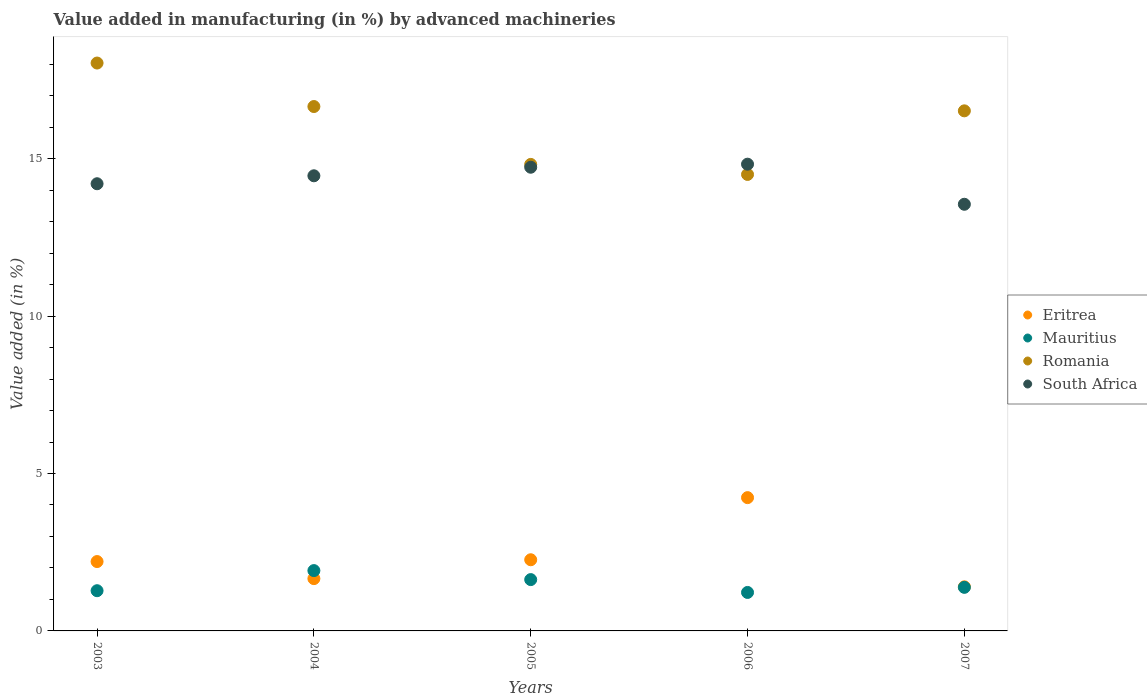How many different coloured dotlines are there?
Offer a very short reply. 4. Is the number of dotlines equal to the number of legend labels?
Offer a very short reply. Yes. What is the percentage of value added in manufacturing by advanced machineries in South Africa in 2003?
Offer a terse response. 14.2. Across all years, what is the maximum percentage of value added in manufacturing by advanced machineries in Eritrea?
Keep it short and to the point. 4.23. Across all years, what is the minimum percentage of value added in manufacturing by advanced machineries in Eritrea?
Provide a short and direct response. 1.4. In which year was the percentage of value added in manufacturing by advanced machineries in South Africa maximum?
Make the answer very short. 2006. In which year was the percentage of value added in manufacturing by advanced machineries in Mauritius minimum?
Give a very brief answer. 2006. What is the total percentage of value added in manufacturing by advanced machineries in Eritrea in the graph?
Your answer should be compact. 11.76. What is the difference between the percentage of value added in manufacturing by advanced machineries in Eritrea in 2003 and that in 2006?
Keep it short and to the point. -2.03. What is the difference between the percentage of value added in manufacturing by advanced machineries in Romania in 2006 and the percentage of value added in manufacturing by advanced machineries in South Africa in 2004?
Offer a very short reply. 0.04. What is the average percentage of value added in manufacturing by advanced machineries in Eritrea per year?
Provide a short and direct response. 2.35. In the year 2005, what is the difference between the percentage of value added in manufacturing by advanced machineries in Romania and percentage of value added in manufacturing by advanced machineries in Mauritius?
Make the answer very short. 13.19. In how many years, is the percentage of value added in manufacturing by advanced machineries in South Africa greater than 3 %?
Your answer should be compact. 5. What is the ratio of the percentage of value added in manufacturing by advanced machineries in Mauritius in 2004 to that in 2007?
Offer a very short reply. 1.38. Is the percentage of value added in manufacturing by advanced machineries in South Africa in 2004 less than that in 2006?
Your answer should be compact. Yes. Is the difference between the percentage of value added in manufacturing by advanced machineries in Romania in 2003 and 2004 greater than the difference between the percentage of value added in manufacturing by advanced machineries in Mauritius in 2003 and 2004?
Keep it short and to the point. Yes. What is the difference between the highest and the second highest percentage of value added in manufacturing by advanced machineries in Romania?
Your answer should be very brief. 1.38. What is the difference between the highest and the lowest percentage of value added in manufacturing by advanced machineries in South Africa?
Make the answer very short. 1.27. In how many years, is the percentage of value added in manufacturing by advanced machineries in Mauritius greater than the average percentage of value added in manufacturing by advanced machineries in Mauritius taken over all years?
Provide a succinct answer. 2. Is it the case that in every year, the sum of the percentage of value added in manufacturing by advanced machineries in Mauritius and percentage of value added in manufacturing by advanced machineries in South Africa  is greater than the sum of percentage of value added in manufacturing by advanced machineries in Eritrea and percentage of value added in manufacturing by advanced machineries in Romania?
Ensure brevity in your answer.  Yes. Is the percentage of value added in manufacturing by advanced machineries in Eritrea strictly greater than the percentage of value added in manufacturing by advanced machineries in South Africa over the years?
Your answer should be compact. No. Is the percentage of value added in manufacturing by advanced machineries in Romania strictly less than the percentage of value added in manufacturing by advanced machineries in Mauritius over the years?
Provide a succinct answer. No. How many dotlines are there?
Your answer should be compact. 4. What is the difference between two consecutive major ticks on the Y-axis?
Make the answer very short. 5. Are the values on the major ticks of Y-axis written in scientific E-notation?
Your answer should be very brief. No. Does the graph contain grids?
Make the answer very short. No. Where does the legend appear in the graph?
Offer a terse response. Center right. How many legend labels are there?
Your answer should be compact. 4. How are the legend labels stacked?
Make the answer very short. Vertical. What is the title of the graph?
Make the answer very short. Value added in manufacturing (in %) by advanced machineries. Does "Myanmar" appear as one of the legend labels in the graph?
Offer a terse response. No. What is the label or title of the Y-axis?
Your response must be concise. Value added (in %). What is the Value added (in %) in Eritrea in 2003?
Keep it short and to the point. 2.2. What is the Value added (in %) of Mauritius in 2003?
Give a very brief answer. 1.28. What is the Value added (in %) of Romania in 2003?
Make the answer very short. 18.04. What is the Value added (in %) in South Africa in 2003?
Give a very brief answer. 14.2. What is the Value added (in %) in Eritrea in 2004?
Offer a very short reply. 1.66. What is the Value added (in %) of Mauritius in 2004?
Keep it short and to the point. 1.92. What is the Value added (in %) in Romania in 2004?
Offer a very short reply. 16.65. What is the Value added (in %) in South Africa in 2004?
Your answer should be compact. 14.45. What is the Value added (in %) in Eritrea in 2005?
Your answer should be very brief. 2.26. What is the Value added (in %) of Mauritius in 2005?
Offer a very short reply. 1.63. What is the Value added (in %) of Romania in 2005?
Make the answer very short. 14.82. What is the Value added (in %) of South Africa in 2005?
Keep it short and to the point. 14.73. What is the Value added (in %) of Eritrea in 2006?
Keep it short and to the point. 4.23. What is the Value added (in %) of Mauritius in 2006?
Offer a terse response. 1.22. What is the Value added (in %) in Romania in 2006?
Offer a very short reply. 14.5. What is the Value added (in %) in South Africa in 2006?
Your response must be concise. 14.82. What is the Value added (in %) in Eritrea in 2007?
Ensure brevity in your answer.  1.4. What is the Value added (in %) of Mauritius in 2007?
Keep it short and to the point. 1.38. What is the Value added (in %) of Romania in 2007?
Give a very brief answer. 16.52. What is the Value added (in %) of South Africa in 2007?
Make the answer very short. 13.55. Across all years, what is the maximum Value added (in %) of Eritrea?
Make the answer very short. 4.23. Across all years, what is the maximum Value added (in %) of Mauritius?
Your response must be concise. 1.92. Across all years, what is the maximum Value added (in %) in Romania?
Ensure brevity in your answer.  18.04. Across all years, what is the maximum Value added (in %) in South Africa?
Make the answer very short. 14.82. Across all years, what is the minimum Value added (in %) in Eritrea?
Your answer should be compact. 1.4. Across all years, what is the minimum Value added (in %) in Mauritius?
Your answer should be very brief. 1.22. Across all years, what is the minimum Value added (in %) of Romania?
Keep it short and to the point. 14.5. Across all years, what is the minimum Value added (in %) of South Africa?
Your response must be concise. 13.55. What is the total Value added (in %) of Eritrea in the graph?
Make the answer very short. 11.76. What is the total Value added (in %) in Mauritius in the graph?
Give a very brief answer. 7.43. What is the total Value added (in %) of Romania in the graph?
Keep it short and to the point. 80.52. What is the total Value added (in %) in South Africa in the graph?
Provide a succinct answer. 71.76. What is the difference between the Value added (in %) in Eritrea in 2003 and that in 2004?
Keep it short and to the point. 0.54. What is the difference between the Value added (in %) in Mauritius in 2003 and that in 2004?
Provide a succinct answer. -0.64. What is the difference between the Value added (in %) in Romania in 2003 and that in 2004?
Provide a succinct answer. 1.38. What is the difference between the Value added (in %) in South Africa in 2003 and that in 2004?
Your answer should be very brief. -0.25. What is the difference between the Value added (in %) of Eritrea in 2003 and that in 2005?
Offer a very short reply. -0.06. What is the difference between the Value added (in %) of Mauritius in 2003 and that in 2005?
Make the answer very short. -0.35. What is the difference between the Value added (in %) in Romania in 2003 and that in 2005?
Your answer should be compact. 3.22. What is the difference between the Value added (in %) of South Africa in 2003 and that in 2005?
Provide a succinct answer. -0.52. What is the difference between the Value added (in %) of Eritrea in 2003 and that in 2006?
Give a very brief answer. -2.03. What is the difference between the Value added (in %) of Mauritius in 2003 and that in 2006?
Your answer should be compact. 0.06. What is the difference between the Value added (in %) of Romania in 2003 and that in 2006?
Your answer should be very brief. 3.54. What is the difference between the Value added (in %) in South Africa in 2003 and that in 2006?
Provide a succinct answer. -0.62. What is the difference between the Value added (in %) of Eritrea in 2003 and that in 2007?
Offer a very short reply. 0.8. What is the difference between the Value added (in %) of Mauritius in 2003 and that in 2007?
Keep it short and to the point. -0.11. What is the difference between the Value added (in %) of Romania in 2003 and that in 2007?
Provide a succinct answer. 1.52. What is the difference between the Value added (in %) in South Africa in 2003 and that in 2007?
Make the answer very short. 0.65. What is the difference between the Value added (in %) of Eritrea in 2004 and that in 2005?
Offer a very short reply. -0.6. What is the difference between the Value added (in %) in Mauritius in 2004 and that in 2005?
Provide a succinct answer. 0.29. What is the difference between the Value added (in %) in Romania in 2004 and that in 2005?
Make the answer very short. 1.84. What is the difference between the Value added (in %) in South Africa in 2004 and that in 2005?
Your answer should be compact. -0.27. What is the difference between the Value added (in %) in Eritrea in 2004 and that in 2006?
Make the answer very short. -2.57. What is the difference between the Value added (in %) of Mauritius in 2004 and that in 2006?
Offer a terse response. 0.69. What is the difference between the Value added (in %) of Romania in 2004 and that in 2006?
Ensure brevity in your answer.  2.16. What is the difference between the Value added (in %) in South Africa in 2004 and that in 2006?
Your answer should be very brief. -0.37. What is the difference between the Value added (in %) in Eritrea in 2004 and that in 2007?
Provide a short and direct response. 0.26. What is the difference between the Value added (in %) in Mauritius in 2004 and that in 2007?
Keep it short and to the point. 0.53. What is the difference between the Value added (in %) of Romania in 2004 and that in 2007?
Provide a succinct answer. 0.14. What is the difference between the Value added (in %) in South Africa in 2004 and that in 2007?
Your response must be concise. 0.9. What is the difference between the Value added (in %) of Eritrea in 2005 and that in 2006?
Provide a short and direct response. -1.97. What is the difference between the Value added (in %) of Mauritius in 2005 and that in 2006?
Offer a very short reply. 0.41. What is the difference between the Value added (in %) in Romania in 2005 and that in 2006?
Keep it short and to the point. 0.32. What is the difference between the Value added (in %) of South Africa in 2005 and that in 2006?
Provide a short and direct response. -0.1. What is the difference between the Value added (in %) in Eritrea in 2005 and that in 2007?
Your answer should be compact. 0.86. What is the difference between the Value added (in %) of Mauritius in 2005 and that in 2007?
Your answer should be very brief. 0.25. What is the difference between the Value added (in %) of Romania in 2005 and that in 2007?
Ensure brevity in your answer.  -1.7. What is the difference between the Value added (in %) in South Africa in 2005 and that in 2007?
Give a very brief answer. 1.18. What is the difference between the Value added (in %) of Eritrea in 2006 and that in 2007?
Ensure brevity in your answer.  2.83. What is the difference between the Value added (in %) in Mauritius in 2006 and that in 2007?
Give a very brief answer. -0.16. What is the difference between the Value added (in %) of Romania in 2006 and that in 2007?
Keep it short and to the point. -2.02. What is the difference between the Value added (in %) of South Africa in 2006 and that in 2007?
Keep it short and to the point. 1.27. What is the difference between the Value added (in %) in Eritrea in 2003 and the Value added (in %) in Mauritius in 2004?
Ensure brevity in your answer.  0.29. What is the difference between the Value added (in %) of Eritrea in 2003 and the Value added (in %) of Romania in 2004?
Provide a short and direct response. -14.45. What is the difference between the Value added (in %) in Eritrea in 2003 and the Value added (in %) in South Africa in 2004?
Provide a succinct answer. -12.25. What is the difference between the Value added (in %) of Mauritius in 2003 and the Value added (in %) of Romania in 2004?
Provide a succinct answer. -15.38. What is the difference between the Value added (in %) of Mauritius in 2003 and the Value added (in %) of South Africa in 2004?
Give a very brief answer. -13.18. What is the difference between the Value added (in %) in Romania in 2003 and the Value added (in %) in South Africa in 2004?
Give a very brief answer. 3.58. What is the difference between the Value added (in %) in Eritrea in 2003 and the Value added (in %) in Mauritius in 2005?
Your response must be concise. 0.57. What is the difference between the Value added (in %) in Eritrea in 2003 and the Value added (in %) in Romania in 2005?
Make the answer very short. -12.61. What is the difference between the Value added (in %) of Eritrea in 2003 and the Value added (in %) of South Africa in 2005?
Keep it short and to the point. -12.52. What is the difference between the Value added (in %) of Mauritius in 2003 and the Value added (in %) of Romania in 2005?
Make the answer very short. -13.54. What is the difference between the Value added (in %) of Mauritius in 2003 and the Value added (in %) of South Africa in 2005?
Your answer should be compact. -13.45. What is the difference between the Value added (in %) of Romania in 2003 and the Value added (in %) of South Africa in 2005?
Offer a very short reply. 3.31. What is the difference between the Value added (in %) of Eritrea in 2003 and the Value added (in %) of Romania in 2006?
Your answer should be compact. -12.3. What is the difference between the Value added (in %) in Eritrea in 2003 and the Value added (in %) in South Africa in 2006?
Ensure brevity in your answer.  -12.62. What is the difference between the Value added (in %) in Mauritius in 2003 and the Value added (in %) in Romania in 2006?
Make the answer very short. -13.22. What is the difference between the Value added (in %) in Mauritius in 2003 and the Value added (in %) in South Africa in 2006?
Provide a short and direct response. -13.55. What is the difference between the Value added (in %) of Romania in 2003 and the Value added (in %) of South Africa in 2006?
Offer a very short reply. 3.21. What is the difference between the Value added (in %) of Eritrea in 2003 and the Value added (in %) of Mauritius in 2007?
Your response must be concise. 0.82. What is the difference between the Value added (in %) of Eritrea in 2003 and the Value added (in %) of Romania in 2007?
Provide a succinct answer. -14.31. What is the difference between the Value added (in %) of Eritrea in 2003 and the Value added (in %) of South Africa in 2007?
Your answer should be compact. -11.35. What is the difference between the Value added (in %) in Mauritius in 2003 and the Value added (in %) in Romania in 2007?
Keep it short and to the point. -15.24. What is the difference between the Value added (in %) of Mauritius in 2003 and the Value added (in %) of South Africa in 2007?
Provide a succinct answer. -12.27. What is the difference between the Value added (in %) of Romania in 2003 and the Value added (in %) of South Africa in 2007?
Keep it short and to the point. 4.49. What is the difference between the Value added (in %) in Eritrea in 2004 and the Value added (in %) in Mauritius in 2005?
Offer a very short reply. 0.03. What is the difference between the Value added (in %) in Eritrea in 2004 and the Value added (in %) in Romania in 2005?
Your answer should be very brief. -13.15. What is the difference between the Value added (in %) of Eritrea in 2004 and the Value added (in %) of South Africa in 2005?
Your response must be concise. -13.07. What is the difference between the Value added (in %) in Mauritius in 2004 and the Value added (in %) in Romania in 2005?
Offer a terse response. -12.9. What is the difference between the Value added (in %) in Mauritius in 2004 and the Value added (in %) in South Africa in 2005?
Give a very brief answer. -12.81. What is the difference between the Value added (in %) in Romania in 2004 and the Value added (in %) in South Africa in 2005?
Provide a short and direct response. 1.93. What is the difference between the Value added (in %) of Eritrea in 2004 and the Value added (in %) of Mauritius in 2006?
Provide a short and direct response. 0.44. What is the difference between the Value added (in %) in Eritrea in 2004 and the Value added (in %) in Romania in 2006?
Keep it short and to the point. -12.84. What is the difference between the Value added (in %) of Eritrea in 2004 and the Value added (in %) of South Africa in 2006?
Your answer should be very brief. -13.16. What is the difference between the Value added (in %) of Mauritius in 2004 and the Value added (in %) of Romania in 2006?
Give a very brief answer. -12.58. What is the difference between the Value added (in %) in Mauritius in 2004 and the Value added (in %) in South Africa in 2006?
Offer a very short reply. -12.91. What is the difference between the Value added (in %) of Romania in 2004 and the Value added (in %) of South Africa in 2006?
Your answer should be compact. 1.83. What is the difference between the Value added (in %) in Eritrea in 2004 and the Value added (in %) in Mauritius in 2007?
Make the answer very short. 0.28. What is the difference between the Value added (in %) in Eritrea in 2004 and the Value added (in %) in Romania in 2007?
Ensure brevity in your answer.  -14.86. What is the difference between the Value added (in %) of Eritrea in 2004 and the Value added (in %) of South Africa in 2007?
Provide a succinct answer. -11.89. What is the difference between the Value added (in %) in Mauritius in 2004 and the Value added (in %) in Romania in 2007?
Give a very brief answer. -14.6. What is the difference between the Value added (in %) of Mauritius in 2004 and the Value added (in %) of South Africa in 2007?
Keep it short and to the point. -11.63. What is the difference between the Value added (in %) in Romania in 2004 and the Value added (in %) in South Africa in 2007?
Give a very brief answer. 3.1. What is the difference between the Value added (in %) in Eritrea in 2005 and the Value added (in %) in Mauritius in 2006?
Offer a terse response. 1.04. What is the difference between the Value added (in %) of Eritrea in 2005 and the Value added (in %) of Romania in 2006?
Ensure brevity in your answer.  -12.24. What is the difference between the Value added (in %) in Eritrea in 2005 and the Value added (in %) in South Africa in 2006?
Your answer should be compact. -12.56. What is the difference between the Value added (in %) in Mauritius in 2005 and the Value added (in %) in Romania in 2006?
Your answer should be very brief. -12.87. What is the difference between the Value added (in %) of Mauritius in 2005 and the Value added (in %) of South Africa in 2006?
Provide a short and direct response. -13.19. What is the difference between the Value added (in %) of Romania in 2005 and the Value added (in %) of South Africa in 2006?
Your answer should be compact. -0.01. What is the difference between the Value added (in %) in Eritrea in 2005 and the Value added (in %) in Mauritius in 2007?
Keep it short and to the point. 0.88. What is the difference between the Value added (in %) in Eritrea in 2005 and the Value added (in %) in Romania in 2007?
Make the answer very short. -14.26. What is the difference between the Value added (in %) in Eritrea in 2005 and the Value added (in %) in South Africa in 2007?
Offer a very short reply. -11.29. What is the difference between the Value added (in %) of Mauritius in 2005 and the Value added (in %) of Romania in 2007?
Ensure brevity in your answer.  -14.89. What is the difference between the Value added (in %) in Mauritius in 2005 and the Value added (in %) in South Africa in 2007?
Offer a terse response. -11.92. What is the difference between the Value added (in %) of Romania in 2005 and the Value added (in %) of South Africa in 2007?
Offer a very short reply. 1.27. What is the difference between the Value added (in %) of Eritrea in 2006 and the Value added (in %) of Mauritius in 2007?
Provide a short and direct response. 2.85. What is the difference between the Value added (in %) in Eritrea in 2006 and the Value added (in %) in Romania in 2007?
Your answer should be very brief. -12.28. What is the difference between the Value added (in %) of Eritrea in 2006 and the Value added (in %) of South Africa in 2007?
Your response must be concise. -9.32. What is the difference between the Value added (in %) of Mauritius in 2006 and the Value added (in %) of Romania in 2007?
Provide a succinct answer. -15.3. What is the difference between the Value added (in %) of Mauritius in 2006 and the Value added (in %) of South Africa in 2007?
Keep it short and to the point. -12.33. What is the difference between the Value added (in %) in Romania in 2006 and the Value added (in %) in South Africa in 2007?
Make the answer very short. 0.95. What is the average Value added (in %) of Eritrea per year?
Give a very brief answer. 2.35. What is the average Value added (in %) of Mauritius per year?
Give a very brief answer. 1.49. What is the average Value added (in %) in Romania per year?
Provide a succinct answer. 16.1. What is the average Value added (in %) of South Africa per year?
Offer a terse response. 14.35. In the year 2003, what is the difference between the Value added (in %) of Eritrea and Value added (in %) of Mauritius?
Offer a very short reply. 0.93. In the year 2003, what is the difference between the Value added (in %) of Eritrea and Value added (in %) of Romania?
Your response must be concise. -15.83. In the year 2003, what is the difference between the Value added (in %) of Eritrea and Value added (in %) of South Africa?
Your response must be concise. -12. In the year 2003, what is the difference between the Value added (in %) of Mauritius and Value added (in %) of Romania?
Make the answer very short. -16.76. In the year 2003, what is the difference between the Value added (in %) of Mauritius and Value added (in %) of South Africa?
Offer a terse response. -12.92. In the year 2003, what is the difference between the Value added (in %) in Romania and Value added (in %) in South Africa?
Ensure brevity in your answer.  3.83. In the year 2004, what is the difference between the Value added (in %) in Eritrea and Value added (in %) in Mauritius?
Ensure brevity in your answer.  -0.25. In the year 2004, what is the difference between the Value added (in %) of Eritrea and Value added (in %) of Romania?
Your answer should be very brief. -14.99. In the year 2004, what is the difference between the Value added (in %) of Eritrea and Value added (in %) of South Africa?
Your answer should be very brief. -12.79. In the year 2004, what is the difference between the Value added (in %) in Mauritius and Value added (in %) in Romania?
Your answer should be very brief. -14.74. In the year 2004, what is the difference between the Value added (in %) in Mauritius and Value added (in %) in South Africa?
Offer a terse response. -12.54. In the year 2004, what is the difference between the Value added (in %) of Romania and Value added (in %) of South Africa?
Provide a short and direct response. 2.2. In the year 2005, what is the difference between the Value added (in %) of Eritrea and Value added (in %) of Mauritius?
Your answer should be compact. 0.63. In the year 2005, what is the difference between the Value added (in %) of Eritrea and Value added (in %) of Romania?
Offer a very short reply. -12.56. In the year 2005, what is the difference between the Value added (in %) in Eritrea and Value added (in %) in South Africa?
Your response must be concise. -12.47. In the year 2005, what is the difference between the Value added (in %) of Mauritius and Value added (in %) of Romania?
Offer a terse response. -13.19. In the year 2005, what is the difference between the Value added (in %) of Mauritius and Value added (in %) of South Africa?
Offer a terse response. -13.1. In the year 2005, what is the difference between the Value added (in %) of Romania and Value added (in %) of South Africa?
Keep it short and to the point. 0.09. In the year 2006, what is the difference between the Value added (in %) of Eritrea and Value added (in %) of Mauritius?
Offer a very short reply. 3.01. In the year 2006, what is the difference between the Value added (in %) of Eritrea and Value added (in %) of Romania?
Offer a terse response. -10.27. In the year 2006, what is the difference between the Value added (in %) in Eritrea and Value added (in %) in South Africa?
Your response must be concise. -10.59. In the year 2006, what is the difference between the Value added (in %) in Mauritius and Value added (in %) in Romania?
Your answer should be very brief. -13.28. In the year 2006, what is the difference between the Value added (in %) of Mauritius and Value added (in %) of South Africa?
Your response must be concise. -13.6. In the year 2006, what is the difference between the Value added (in %) of Romania and Value added (in %) of South Africa?
Make the answer very short. -0.33. In the year 2007, what is the difference between the Value added (in %) in Eritrea and Value added (in %) in Mauritius?
Provide a succinct answer. 0.02. In the year 2007, what is the difference between the Value added (in %) of Eritrea and Value added (in %) of Romania?
Provide a succinct answer. -15.12. In the year 2007, what is the difference between the Value added (in %) in Eritrea and Value added (in %) in South Africa?
Keep it short and to the point. -12.15. In the year 2007, what is the difference between the Value added (in %) of Mauritius and Value added (in %) of Romania?
Offer a terse response. -15.13. In the year 2007, what is the difference between the Value added (in %) in Mauritius and Value added (in %) in South Africa?
Provide a succinct answer. -12.17. In the year 2007, what is the difference between the Value added (in %) in Romania and Value added (in %) in South Africa?
Offer a very short reply. 2.97. What is the ratio of the Value added (in %) of Eritrea in 2003 to that in 2004?
Offer a terse response. 1.33. What is the ratio of the Value added (in %) in Romania in 2003 to that in 2004?
Your answer should be very brief. 1.08. What is the ratio of the Value added (in %) in South Africa in 2003 to that in 2004?
Your response must be concise. 0.98. What is the ratio of the Value added (in %) of Eritrea in 2003 to that in 2005?
Provide a short and direct response. 0.97. What is the ratio of the Value added (in %) of Mauritius in 2003 to that in 2005?
Provide a short and direct response. 0.78. What is the ratio of the Value added (in %) in Romania in 2003 to that in 2005?
Keep it short and to the point. 1.22. What is the ratio of the Value added (in %) of South Africa in 2003 to that in 2005?
Ensure brevity in your answer.  0.96. What is the ratio of the Value added (in %) of Eritrea in 2003 to that in 2006?
Ensure brevity in your answer.  0.52. What is the ratio of the Value added (in %) of Mauritius in 2003 to that in 2006?
Your response must be concise. 1.05. What is the ratio of the Value added (in %) of Romania in 2003 to that in 2006?
Your response must be concise. 1.24. What is the ratio of the Value added (in %) of South Africa in 2003 to that in 2006?
Your answer should be very brief. 0.96. What is the ratio of the Value added (in %) in Eritrea in 2003 to that in 2007?
Make the answer very short. 1.57. What is the ratio of the Value added (in %) of Mauritius in 2003 to that in 2007?
Offer a terse response. 0.92. What is the ratio of the Value added (in %) in Romania in 2003 to that in 2007?
Your answer should be compact. 1.09. What is the ratio of the Value added (in %) of South Africa in 2003 to that in 2007?
Give a very brief answer. 1.05. What is the ratio of the Value added (in %) in Eritrea in 2004 to that in 2005?
Keep it short and to the point. 0.73. What is the ratio of the Value added (in %) of Mauritius in 2004 to that in 2005?
Make the answer very short. 1.18. What is the ratio of the Value added (in %) of Romania in 2004 to that in 2005?
Make the answer very short. 1.12. What is the ratio of the Value added (in %) in South Africa in 2004 to that in 2005?
Provide a short and direct response. 0.98. What is the ratio of the Value added (in %) of Eritrea in 2004 to that in 2006?
Your response must be concise. 0.39. What is the ratio of the Value added (in %) in Mauritius in 2004 to that in 2006?
Your answer should be very brief. 1.57. What is the ratio of the Value added (in %) in Romania in 2004 to that in 2006?
Provide a short and direct response. 1.15. What is the ratio of the Value added (in %) of South Africa in 2004 to that in 2006?
Ensure brevity in your answer.  0.98. What is the ratio of the Value added (in %) of Eritrea in 2004 to that in 2007?
Your response must be concise. 1.19. What is the ratio of the Value added (in %) of Mauritius in 2004 to that in 2007?
Ensure brevity in your answer.  1.38. What is the ratio of the Value added (in %) in Romania in 2004 to that in 2007?
Provide a succinct answer. 1.01. What is the ratio of the Value added (in %) of South Africa in 2004 to that in 2007?
Offer a very short reply. 1.07. What is the ratio of the Value added (in %) in Eritrea in 2005 to that in 2006?
Your answer should be compact. 0.53. What is the ratio of the Value added (in %) of Mauritius in 2005 to that in 2006?
Your answer should be compact. 1.33. What is the ratio of the Value added (in %) of Romania in 2005 to that in 2006?
Your answer should be compact. 1.02. What is the ratio of the Value added (in %) in Eritrea in 2005 to that in 2007?
Ensure brevity in your answer.  1.61. What is the ratio of the Value added (in %) of Mauritius in 2005 to that in 2007?
Ensure brevity in your answer.  1.18. What is the ratio of the Value added (in %) of Romania in 2005 to that in 2007?
Offer a very short reply. 0.9. What is the ratio of the Value added (in %) in South Africa in 2005 to that in 2007?
Provide a short and direct response. 1.09. What is the ratio of the Value added (in %) in Eritrea in 2006 to that in 2007?
Your response must be concise. 3.02. What is the ratio of the Value added (in %) of Mauritius in 2006 to that in 2007?
Make the answer very short. 0.88. What is the ratio of the Value added (in %) of Romania in 2006 to that in 2007?
Provide a succinct answer. 0.88. What is the ratio of the Value added (in %) of South Africa in 2006 to that in 2007?
Keep it short and to the point. 1.09. What is the difference between the highest and the second highest Value added (in %) of Eritrea?
Ensure brevity in your answer.  1.97. What is the difference between the highest and the second highest Value added (in %) of Mauritius?
Provide a short and direct response. 0.29. What is the difference between the highest and the second highest Value added (in %) of Romania?
Provide a short and direct response. 1.38. What is the difference between the highest and the second highest Value added (in %) of South Africa?
Give a very brief answer. 0.1. What is the difference between the highest and the lowest Value added (in %) in Eritrea?
Give a very brief answer. 2.83. What is the difference between the highest and the lowest Value added (in %) in Mauritius?
Offer a terse response. 0.69. What is the difference between the highest and the lowest Value added (in %) of Romania?
Provide a succinct answer. 3.54. What is the difference between the highest and the lowest Value added (in %) of South Africa?
Offer a very short reply. 1.27. 